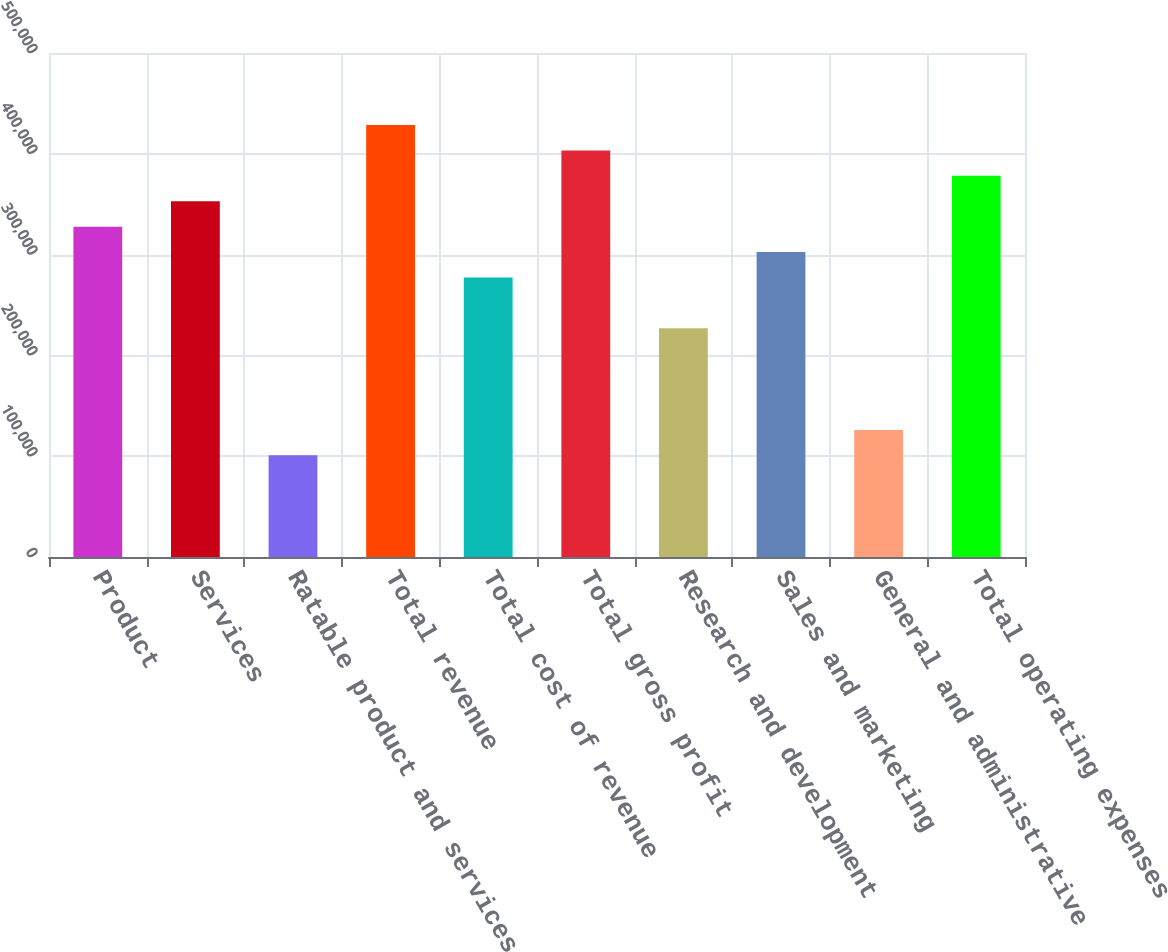<chart> <loc_0><loc_0><loc_500><loc_500><bar_chart><fcel>Product<fcel>Services<fcel>Ratable product and services<fcel>Total revenue<fcel>Total cost of revenue<fcel>Total gross profit<fcel>Research and development<fcel>Sales and marketing<fcel>General and administrative<fcel>Total operating expenses<nl><fcel>327749<fcel>352961<fcel>100846<fcel>428595<fcel>277326<fcel>403384<fcel>226904<fcel>302538<fcel>126058<fcel>378172<nl></chart> 